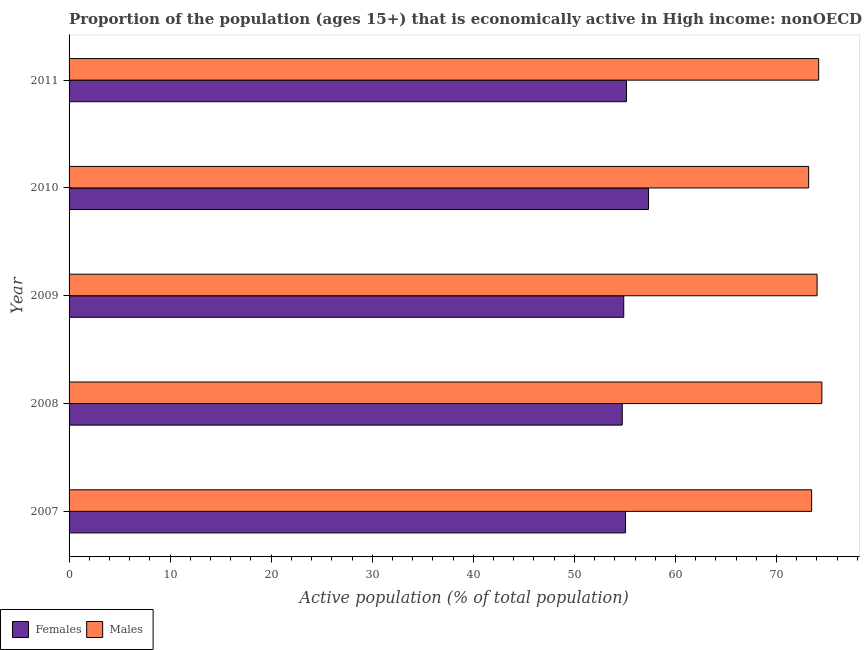How many different coloured bars are there?
Offer a very short reply. 2. How many groups of bars are there?
Your response must be concise. 5. Are the number of bars per tick equal to the number of legend labels?
Your answer should be very brief. Yes. Are the number of bars on each tick of the Y-axis equal?
Provide a succinct answer. Yes. How many bars are there on the 2nd tick from the bottom?
Offer a terse response. 2. What is the label of the 1st group of bars from the top?
Your answer should be compact. 2011. In how many cases, is the number of bars for a given year not equal to the number of legend labels?
Make the answer very short. 0. What is the percentage of economically active female population in 2007?
Provide a succinct answer. 55.06. Across all years, what is the maximum percentage of economically active female population?
Make the answer very short. 57.34. Across all years, what is the minimum percentage of economically active female population?
Your answer should be compact. 54.74. What is the total percentage of economically active female population in the graph?
Your answer should be compact. 277.17. What is the difference between the percentage of economically active female population in 2008 and that in 2009?
Keep it short and to the point. -0.15. What is the difference between the percentage of economically active female population in 2010 and the percentage of economically active male population in 2008?
Your answer should be compact. -17.15. What is the average percentage of economically active male population per year?
Give a very brief answer. 73.87. In the year 2011, what is the difference between the percentage of economically active male population and percentage of economically active female population?
Offer a terse response. 19.01. What is the ratio of the percentage of economically active male population in 2008 to that in 2010?
Offer a terse response. 1.02. Is the percentage of economically active female population in 2007 less than that in 2011?
Keep it short and to the point. Yes. What is the difference between the highest and the second highest percentage of economically active female population?
Give a very brief answer. 2.18. In how many years, is the percentage of economically active female population greater than the average percentage of economically active female population taken over all years?
Your answer should be very brief. 1. Is the sum of the percentage of economically active female population in 2008 and 2011 greater than the maximum percentage of economically active male population across all years?
Your answer should be compact. Yes. What does the 1st bar from the top in 2007 represents?
Offer a terse response. Males. What does the 2nd bar from the bottom in 2009 represents?
Give a very brief answer. Males. How many bars are there?
Provide a succinct answer. 10. What is the difference between two consecutive major ticks on the X-axis?
Offer a very short reply. 10. Are the values on the major ticks of X-axis written in scientific E-notation?
Your answer should be very brief. No. Does the graph contain grids?
Keep it short and to the point. No. Where does the legend appear in the graph?
Offer a terse response. Bottom left. What is the title of the graph?
Your answer should be very brief. Proportion of the population (ages 15+) that is economically active in High income: nonOECD. Does "Total Population" appear as one of the legend labels in the graph?
Your response must be concise. No. What is the label or title of the X-axis?
Offer a terse response. Active population (% of total population). What is the Active population (% of total population) in Females in 2007?
Your response must be concise. 55.06. What is the Active population (% of total population) in Males in 2007?
Offer a terse response. 73.48. What is the Active population (% of total population) of Females in 2008?
Make the answer very short. 54.74. What is the Active population (% of total population) in Males in 2008?
Make the answer very short. 74.49. What is the Active population (% of total population) of Females in 2009?
Provide a succinct answer. 54.88. What is the Active population (% of total population) in Males in 2009?
Ensure brevity in your answer.  74.02. What is the Active population (% of total population) in Females in 2010?
Offer a terse response. 57.34. What is the Active population (% of total population) of Males in 2010?
Keep it short and to the point. 73.18. What is the Active population (% of total population) of Females in 2011?
Ensure brevity in your answer.  55.16. What is the Active population (% of total population) of Males in 2011?
Ensure brevity in your answer.  74.17. Across all years, what is the maximum Active population (% of total population) of Females?
Offer a very short reply. 57.34. Across all years, what is the maximum Active population (% of total population) of Males?
Offer a very short reply. 74.49. Across all years, what is the minimum Active population (% of total population) of Females?
Your answer should be very brief. 54.74. Across all years, what is the minimum Active population (% of total population) in Males?
Provide a short and direct response. 73.18. What is the total Active population (% of total population) in Females in the graph?
Your response must be concise. 277.17. What is the total Active population (% of total population) in Males in the graph?
Offer a terse response. 369.33. What is the difference between the Active population (% of total population) in Females in 2007 and that in 2008?
Give a very brief answer. 0.32. What is the difference between the Active population (% of total population) of Males in 2007 and that in 2008?
Keep it short and to the point. -1.01. What is the difference between the Active population (% of total population) of Females in 2007 and that in 2009?
Your answer should be compact. 0.18. What is the difference between the Active population (% of total population) in Males in 2007 and that in 2009?
Ensure brevity in your answer.  -0.54. What is the difference between the Active population (% of total population) of Females in 2007 and that in 2010?
Provide a short and direct response. -2.28. What is the difference between the Active population (% of total population) in Males in 2007 and that in 2010?
Ensure brevity in your answer.  0.29. What is the difference between the Active population (% of total population) in Females in 2007 and that in 2011?
Give a very brief answer. -0.1. What is the difference between the Active population (% of total population) of Males in 2007 and that in 2011?
Your answer should be compact. -0.69. What is the difference between the Active population (% of total population) in Females in 2008 and that in 2009?
Your answer should be very brief. -0.15. What is the difference between the Active population (% of total population) in Males in 2008 and that in 2009?
Keep it short and to the point. 0.47. What is the difference between the Active population (% of total population) in Females in 2008 and that in 2010?
Keep it short and to the point. -2.6. What is the difference between the Active population (% of total population) in Males in 2008 and that in 2010?
Offer a terse response. 1.3. What is the difference between the Active population (% of total population) in Females in 2008 and that in 2011?
Your answer should be compact. -0.42. What is the difference between the Active population (% of total population) of Males in 2008 and that in 2011?
Offer a very short reply. 0.32. What is the difference between the Active population (% of total population) of Females in 2009 and that in 2010?
Keep it short and to the point. -2.45. What is the difference between the Active population (% of total population) in Males in 2009 and that in 2010?
Ensure brevity in your answer.  0.83. What is the difference between the Active population (% of total population) of Females in 2009 and that in 2011?
Make the answer very short. -0.27. What is the difference between the Active population (% of total population) of Males in 2009 and that in 2011?
Provide a short and direct response. -0.16. What is the difference between the Active population (% of total population) of Females in 2010 and that in 2011?
Provide a succinct answer. 2.18. What is the difference between the Active population (% of total population) in Males in 2010 and that in 2011?
Make the answer very short. -0.99. What is the difference between the Active population (% of total population) of Females in 2007 and the Active population (% of total population) of Males in 2008?
Keep it short and to the point. -19.43. What is the difference between the Active population (% of total population) in Females in 2007 and the Active population (% of total population) in Males in 2009?
Make the answer very short. -18.95. What is the difference between the Active population (% of total population) in Females in 2007 and the Active population (% of total population) in Males in 2010?
Provide a short and direct response. -18.12. What is the difference between the Active population (% of total population) in Females in 2007 and the Active population (% of total population) in Males in 2011?
Offer a very short reply. -19.11. What is the difference between the Active population (% of total population) of Females in 2008 and the Active population (% of total population) of Males in 2009?
Offer a very short reply. -19.28. What is the difference between the Active population (% of total population) of Females in 2008 and the Active population (% of total population) of Males in 2010?
Provide a succinct answer. -18.45. What is the difference between the Active population (% of total population) in Females in 2008 and the Active population (% of total population) in Males in 2011?
Ensure brevity in your answer.  -19.43. What is the difference between the Active population (% of total population) in Females in 2009 and the Active population (% of total population) in Males in 2010?
Provide a succinct answer. -18.3. What is the difference between the Active population (% of total population) in Females in 2009 and the Active population (% of total population) in Males in 2011?
Give a very brief answer. -19.29. What is the difference between the Active population (% of total population) in Females in 2010 and the Active population (% of total population) in Males in 2011?
Offer a very short reply. -16.84. What is the average Active population (% of total population) in Females per year?
Ensure brevity in your answer.  55.43. What is the average Active population (% of total population) in Males per year?
Your answer should be very brief. 73.87. In the year 2007, what is the difference between the Active population (% of total population) of Females and Active population (% of total population) of Males?
Offer a very short reply. -18.42. In the year 2008, what is the difference between the Active population (% of total population) in Females and Active population (% of total population) in Males?
Provide a succinct answer. -19.75. In the year 2009, what is the difference between the Active population (% of total population) of Females and Active population (% of total population) of Males?
Offer a very short reply. -19.13. In the year 2010, what is the difference between the Active population (% of total population) in Females and Active population (% of total population) in Males?
Keep it short and to the point. -15.85. In the year 2011, what is the difference between the Active population (% of total population) of Females and Active population (% of total population) of Males?
Provide a succinct answer. -19.01. What is the ratio of the Active population (% of total population) of Females in 2007 to that in 2008?
Give a very brief answer. 1.01. What is the ratio of the Active population (% of total population) of Males in 2007 to that in 2008?
Provide a short and direct response. 0.99. What is the ratio of the Active population (% of total population) in Females in 2007 to that in 2010?
Keep it short and to the point. 0.96. What is the ratio of the Active population (% of total population) in Females in 2008 to that in 2009?
Your response must be concise. 1. What is the ratio of the Active population (% of total population) of Males in 2008 to that in 2009?
Offer a very short reply. 1.01. What is the ratio of the Active population (% of total population) in Females in 2008 to that in 2010?
Ensure brevity in your answer.  0.95. What is the ratio of the Active population (% of total population) of Males in 2008 to that in 2010?
Give a very brief answer. 1.02. What is the ratio of the Active population (% of total population) of Males in 2008 to that in 2011?
Your response must be concise. 1. What is the ratio of the Active population (% of total population) in Females in 2009 to that in 2010?
Offer a very short reply. 0.96. What is the ratio of the Active population (% of total population) in Males in 2009 to that in 2010?
Keep it short and to the point. 1.01. What is the ratio of the Active population (% of total population) of Females in 2009 to that in 2011?
Keep it short and to the point. 0.99. What is the ratio of the Active population (% of total population) of Males in 2009 to that in 2011?
Provide a short and direct response. 1. What is the ratio of the Active population (% of total population) in Females in 2010 to that in 2011?
Your response must be concise. 1.04. What is the ratio of the Active population (% of total population) in Males in 2010 to that in 2011?
Provide a short and direct response. 0.99. What is the difference between the highest and the second highest Active population (% of total population) of Females?
Offer a terse response. 2.18. What is the difference between the highest and the second highest Active population (% of total population) of Males?
Your answer should be very brief. 0.32. What is the difference between the highest and the lowest Active population (% of total population) of Females?
Your response must be concise. 2.6. What is the difference between the highest and the lowest Active population (% of total population) in Males?
Provide a succinct answer. 1.3. 